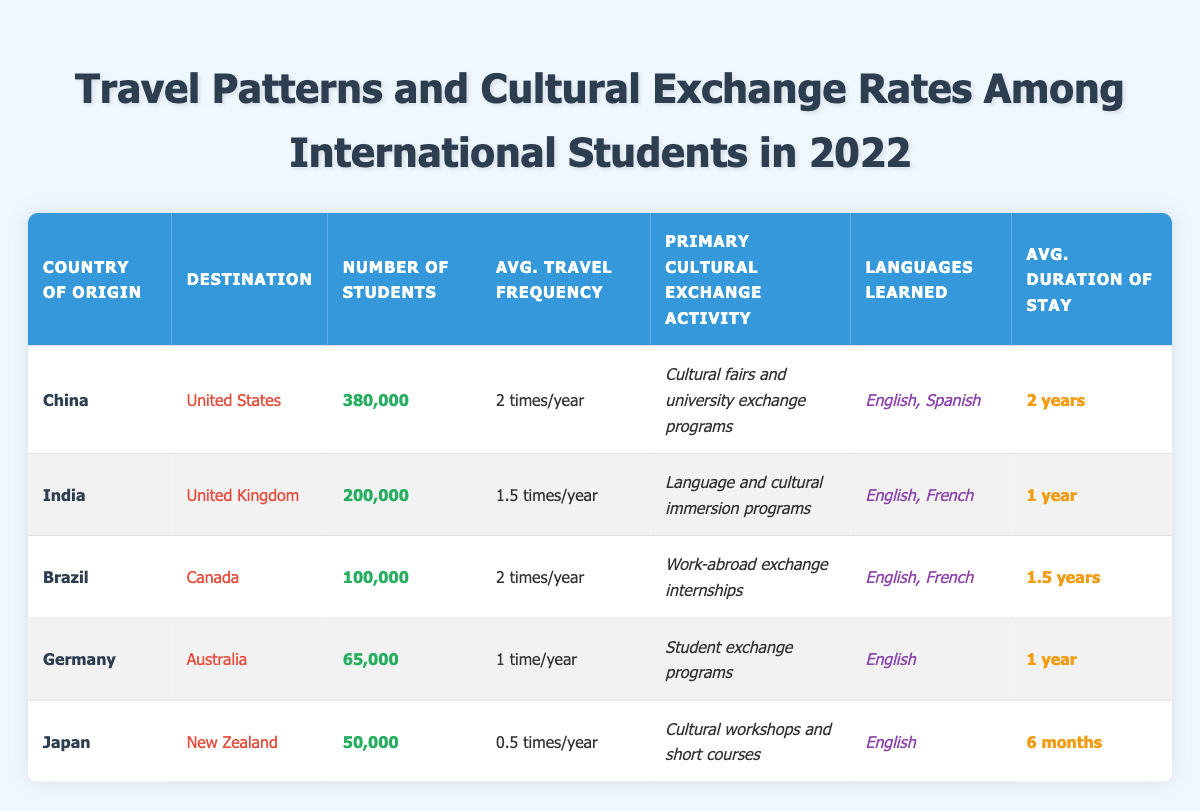What is the number of students traveling from China to the United States? The table directly states that the number of students from China traveling to the United States is 380,000.
Answer: 380,000 Which country has the highest number of students traveling to a destination in 2022? By examining the "Number of Students" column, China has the highest figure at 380,000, compared to other countries.
Answer: China How many languages can Indian students learn during their stay in the UK? According to the table, Indian students learn two languages: English and French, as listed in the respective column.
Answer: 2 What is the average duration of stay for students from Japan in New Zealand? The table indicates that Japanese students have an average stay duration of 6 months in New Zealand, as described in the "Avg. Duration of Stay" column.
Answer: 6 months What is the average travel frequency per year for Brazilian students in Canada? The table specifies that Brazilian students have an average travel frequency of 2 times per year, found in the corresponding column.
Answer: 2 times/year Is it true that students from Germany have a travel frequency greater than 1 time per year? The table states that students from Germany have an average travel frequency of 1 time per year, making the statement false.
Answer: No What is the total number of students represented in this table? By adding the numbers from each country: 380,000 (China) + 200,000 (India) + 100,000 (Brazil) + 65,000 (Germany) + 50,000 (Japan) = 895,000 students total.
Answer: 895,000 How does the average duration of stay for Brazilian students compare to that of Japanese students? Brazilian students have an average duration of stay of 1.5 years, while Japanese students have 6 months. Converting 1.5 years to months (1.5 * 12 = 18 months), Brazilian students stay longer.
Answer: Brazilian students stay longer Which country's students travel the least per year on average? Reviewing the "Avg. Travel Frequency" column, Japanese students in New Zealand travel an average of 0.5 times per year, which is the lowest frequency listed.
Answer: Japan What is the cultural exchange activity preferred by students from India? The table states that the primary cultural exchange activity for Indian students in the UK is "Language and cultural immersion programs," as seen in the corresponding column.
Answer: Language and cultural immersion programs 